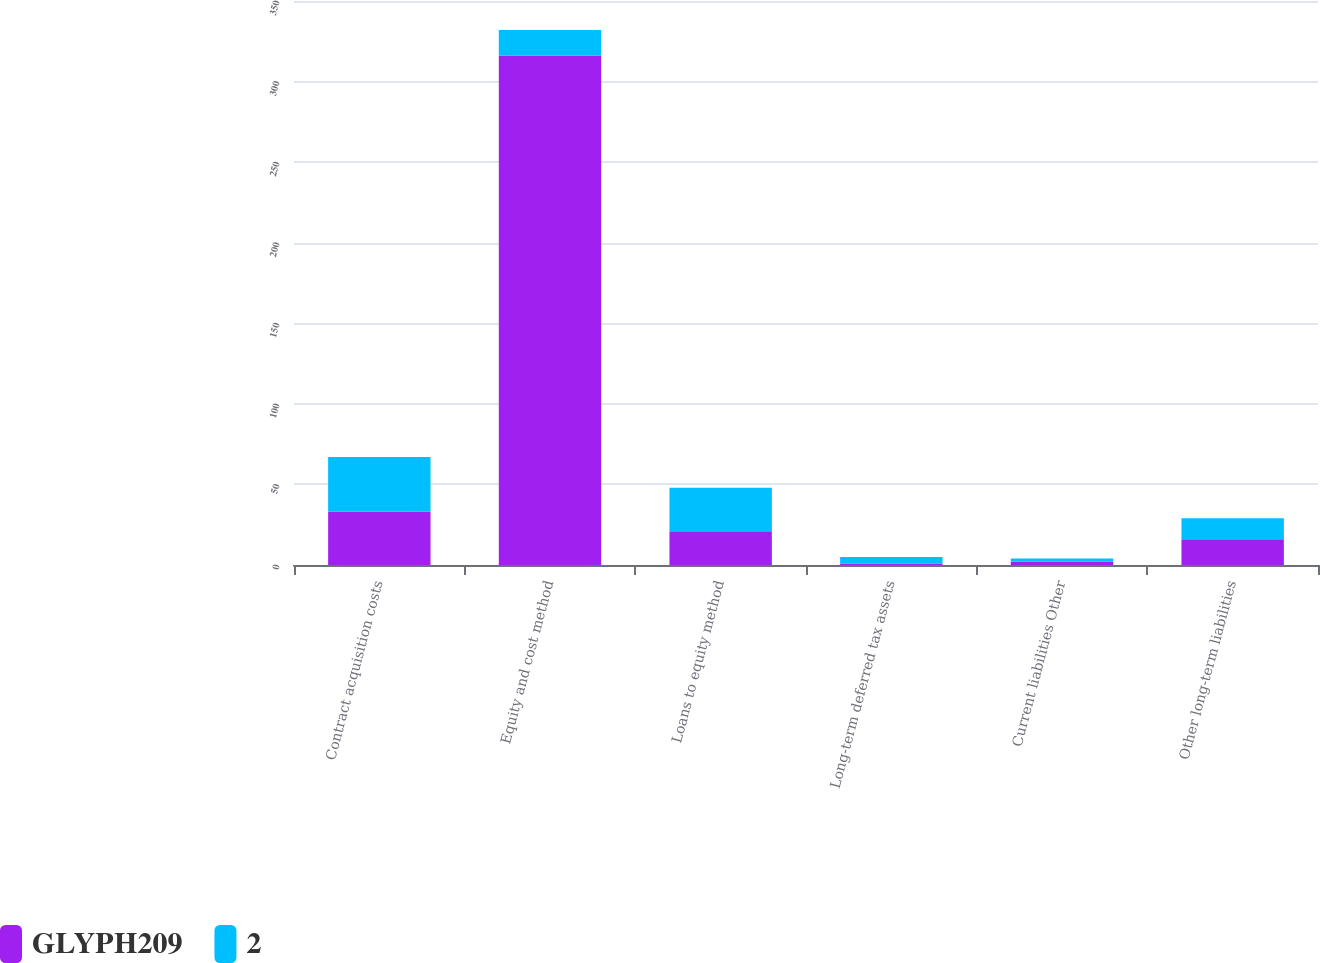Convert chart. <chart><loc_0><loc_0><loc_500><loc_500><stacked_bar_chart><ecel><fcel>Contract acquisition costs<fcel>Equity and cost method<fcel>Loans to equity method<fcel>Long-term deferred tax assets<fcel>Current liabilities Other<fcel>Other long-term liabilities<nl><fcel>GLYPH209<fcel>33<fcel>316<fcel>21<fcel>1<fcel>2<fcel>16<nl><fcel>2<fcel>34<fcel>16<fcel>27<fcel>4<fcel>2<fcel>13<nl></chart> 